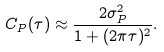<formula> <loc_0><loc_0><loc_500><loc_500>C _ { P } ( \tau ) \approx \frac { 2 \sigma _ { P } ^ { 2 } } { 1 + ( 2 \pi \tau ) ^ { 2 } } .</formula> 